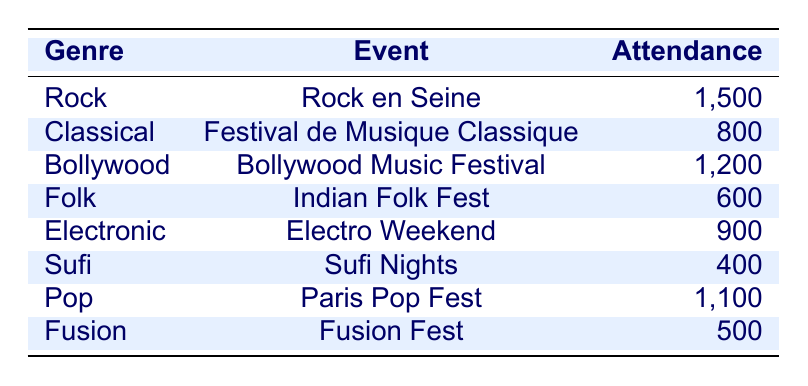What genre had the highest attendance? By examining the attendance figures listed in the table, we can see that the 'Rock' genre had an attendance of 1,500, which is higher than any other genre.
Answer: Rock What was the attendance at the Sufi Nights event? The table shows that the Sufi Nights event had an attendance of 400.
Answer: 400 How many people attended the Bollywood Music Festival and the Paris Pop Fest combined? We look at the attendance for both events: Bollywood Music Festival had 1,200 attendees, and Paris Pop Fest had 1,100 attendees. Adding these together gives 1,200 + 1,100 = 2,300.
Answer: 2300 Is the attendance for the Indian Folk Fest greater than that for the Fusion Fest? The attendance for Indian Folk Fest is 600, while for Fusion Fest it is 500. Since 600 is greater than 500, the statement is true.
Answer: Yes What is the median attendance number among all the listed genres? To find the median, we list the attendance figures: 1,500, 800, 1,200, 600, 900, 400, 1,100, 500. Arranging these in ascending order gives: 400, 500, 600, 800, 900, 1,100, 1,200, 1,500. With 8 data points, the median will be the average of the 4th and 5th numbers: (800 + 900) / 2 = 850.
Answer: 850 How many genres had an attendance of more than 1,000? From the table, we see that three genres - Rock (1,500), Bollywood (1,200), and Pop (1,100) have attendance figures exceeding 1,000. Therefore, there are three such genres.
Answer: 3 